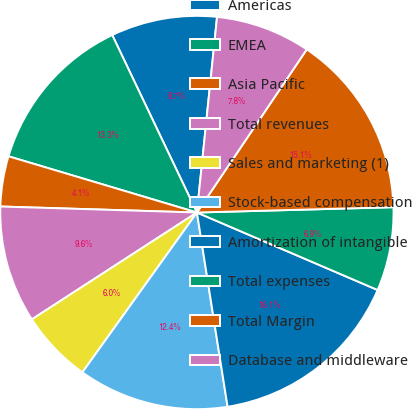Convert chart to OTSL. <chart><loc_0><loc_0><loc_500><loc_500><pie_chart><fcel>Americas<fcel>EMEA<fcel>Asia Pacific<fcel>Total revenues<fcel>Sales and marketing (1)<fcel>Stock-based compensation<fcel>Amortization of intangible<fcel>Total expenses<fcel>Total Margin<fcel>Database and middleware<nl><fcel>8.72%<fcel>13.3%<fcel>4.13%<fcel>9.63%<fcel>5.96%<fcel>12.39%<fcel>16.06%<fcel>6.88%<fcel>15.14%<fcel>7.8%<nl></chart> 